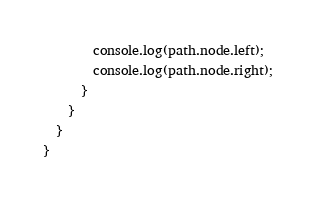Convert code to text. <code><loc_0><loc_0><loc_500><loc_500><_JavaScript_>        console.log(path.node.left);
        console.log(path.node.right);
      }
    }
  }
}</code> 